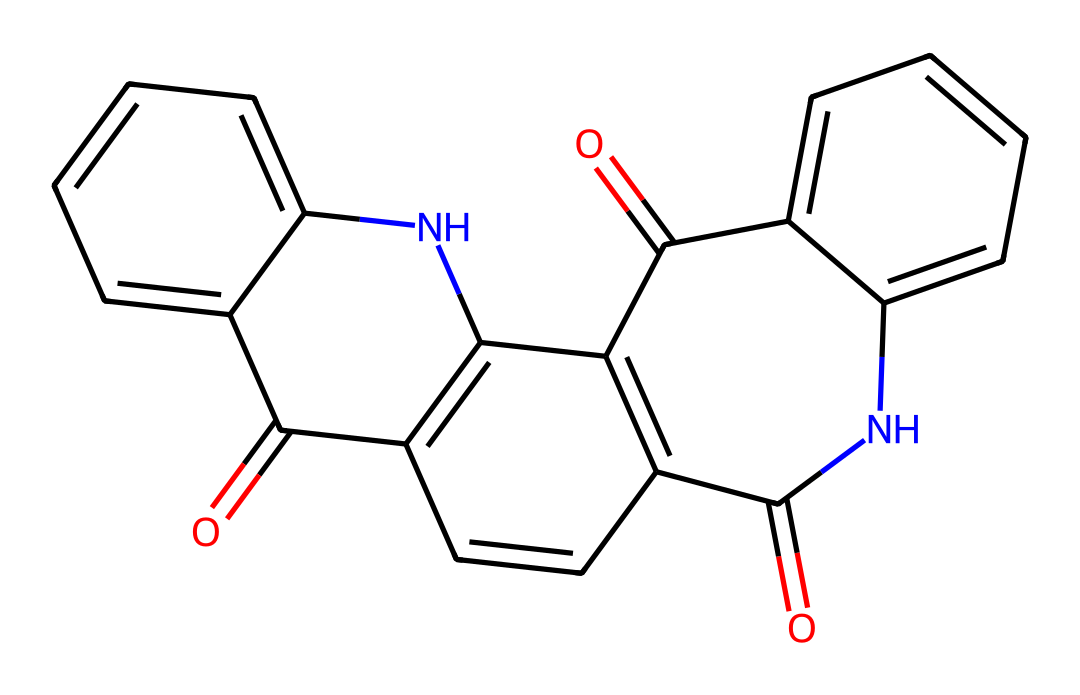How many nitrogen atoms are present in the structure? By analyzing the SMILES representation, we can count the nitrogen (N) atoms. The structure includes two relevant nitrogen atoms at the beginning and within the fused ring structure.
Answer: two What is the molecular formula of Quinacridone magenta? To determine the molecular formula, we interpret the SMILES representation and count the number of each type of atom present in the structure. The breakdown yields: C, H, N, O, leading to the formula C21H12N2O2.
Answer: C21H12N2O2 How many aromatic rings are present in the structure? The structure reveals multiple interconnected rings. Upon examining, we can identify a total of three distinct aromatic rings within the overall structure.
Answer: three What functional groups are present in Quinacridone magenta? By analyzing the structure visually represented in the SMILES, we can identify functional groups. The structure has both ketone (C=O) and aromatic (benzene) functionalities, confirming the presence of these groups.
Answer: ketone and aromatic Which part of the chemical contributes to its magenta color? The presence of the conjugated system of double bonds inherent in the chromophore (the part of the molecule responsible for its color) can be deduced from the arrangement of carbon atoms and double bonds in the structure.
Answer: conjugated system What type of compound is Quinacridone magenta classified as? By analyzing both its structure and the context of its application, Quinacridone magenta is classified as a synthetic dye, primarily recognized for its use in inks and pigments.
Answer: synthetic dye 